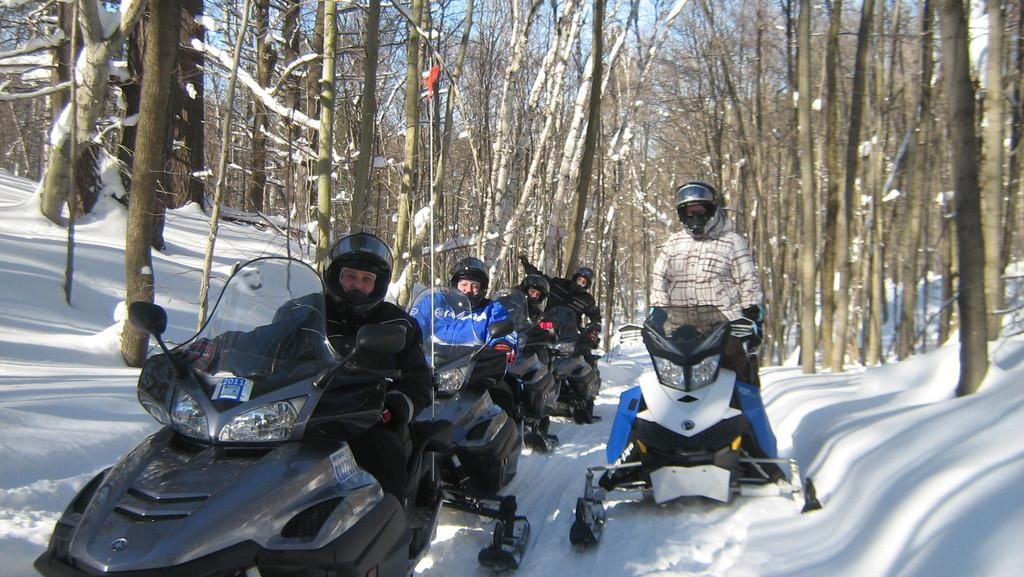What type of vehicles are the people using in the image? There are people on motorbikes in the image. Where are the motorbikes located in the image? The motorbikes are at the bottom of the image. What can be seen in the background of the image? There are trees in the background of the image. What is visible at the top of the image? The sky is visible at the top of the image. What time of day is it in the image, given the presence of morning dew on the motorbikes? There is no mention of dew or any specific time of day in the image, so it cannot be determined from the image alone. 